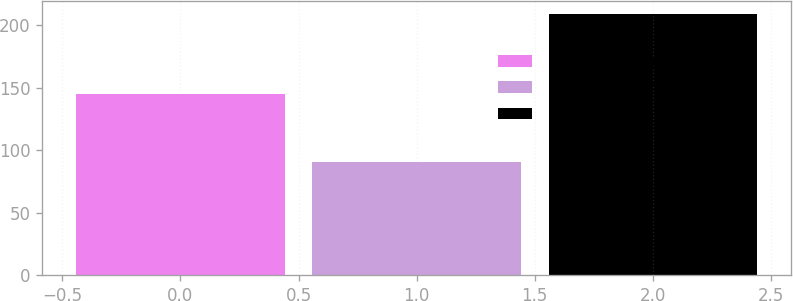Convert chart. <chart><loc_0><loc_0><loc_500><loc_500><bar_chart><fcel>Beginning of year<fcel>Insurance receipts for<fcel>End of year<nl><fcel>145<fcel>91<fcel>209<nl></chart> 